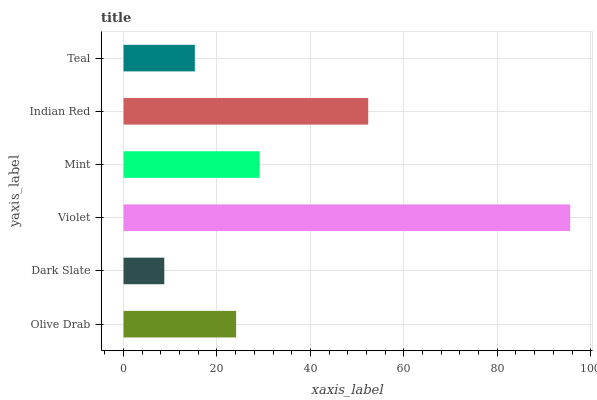Is Dark Slate the minimum?
Answer yes or no. Yes. Is Violet the maximum?
Answer yes or no. Yes. Is Violet the minimum?
Answer yes or no. No. Is Dark Slate the maximum?
Answer yes or no. No. Is Violet greater than Dark Slate?
Answer yes or no. Yes. Is Dark Slate less than Violet?
Answer yes or no. Yes. Is Dark Slate greater than Violet?
Answer yes or no. No. Is Violet less than Dark Slate?
Answer yes or no. No. Is Mint the high median?
Answer yes or no. Yes. Is Olive Drab the low median?
Answer yes or no. Yes. Is Dark Slate the high median?
Answer yes or no. No. Is Mint the low median?
Answer yes or no. No. 